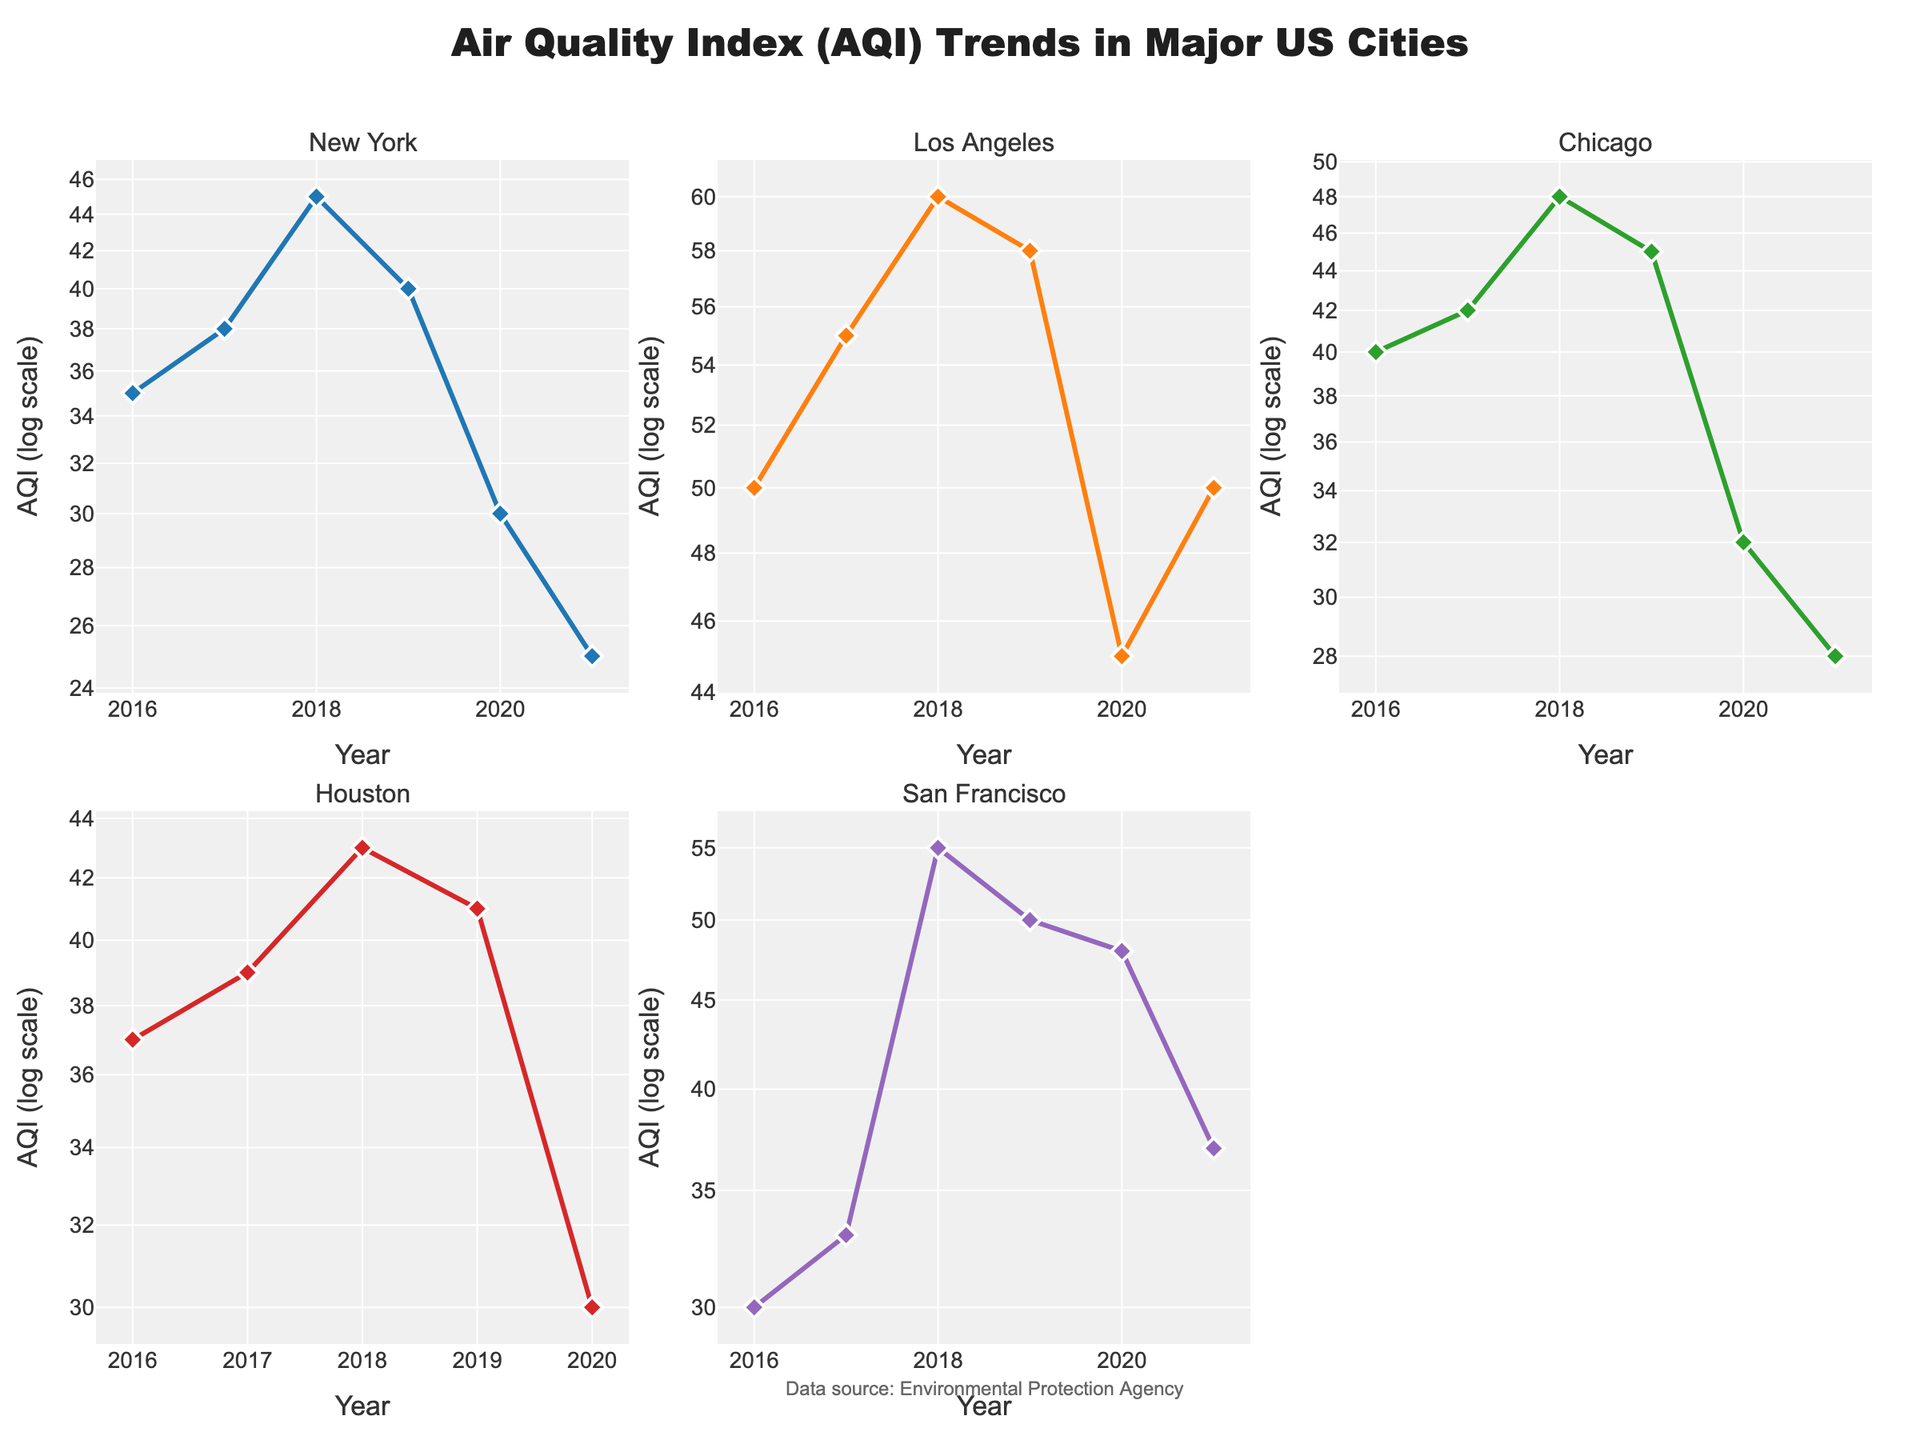What is the title of the plot? The title is placed at the top center of the plot. It indicates the main focus of the data being represented. The title reads "Air Quality Index (AQI) Trends in Major US Cities".
Answer: Air Quality Index (AQI) Trends in Major US Cities How many years of data are plotted for New York City? The x-axis for New York City shows the years. Counting the data points, we can see the years 2016, 2017, 2018, 2019, 2020, and 2021.
Answer: 6 Which city has the highest AQI in 2018 according to the plot? Look for the subplot of each city and identify the AQI value for the year 2018. San Francisco shows an AQI of 55, which is the highest among all cities for that year.
Answer: San Francisco What year shows the lowest AQI for Chicago? Look for the subplot of Chicago and identify the year corresponding to the lowest AQI, which is 2021 with an AQI of 28.
Answer: 2021 Which city shows a decreasing trend in AQI from 2019 to 2021? Examine the subplots for the trend lines from 2019 to 2021. New York and Chicago both show a consistent decrease in AQI during this period.
Answer: New York, Chicago Compare the AQI of Los Angeles and New York in 2020. Which city had a better air quality index? Analyze the subplots for Los Angeles and New York and compare their AQI values for the year 2020. Los Angeles had an AQI of 45, while New York had an AQI of 30. Lower AQI indicates better air quality, so New York had the better air quality index.
Answer: New York What is the average AQI for San Francisco across all years displayed? Add the AQI values for San Francisco (30, 33, 55, 50, 48, 37) and divide by the number of years (6). The sum is 253, and the average is 253/6 = 42.17.
Answer: 42.17 Which city had the smallest year-to-year fluctuation in AQI values? Calculate the year-to-year differences in AQI for each city and identify the city with the smallest overall fluctuations. New York's AQI changes were relatively small and consistent compared to other cities.
Answer: New York On the log scale, do all cities' AQI values show a similar pattern over time? Evaluate the pattern of AQI trends in the log scale for each city. While some cities show similar decreasing trends, others have more variability. Overall, the patterns vary among cities.
Answer: No, patterns vary What is the most significant change in AQI for any city between consecutive years? Identify the largest difference in AQI between any two consecutive years across all cities. San Francisco shows the most significant change between 2017 (33) and 2018 (55), a change of 22.
Answer: 22 